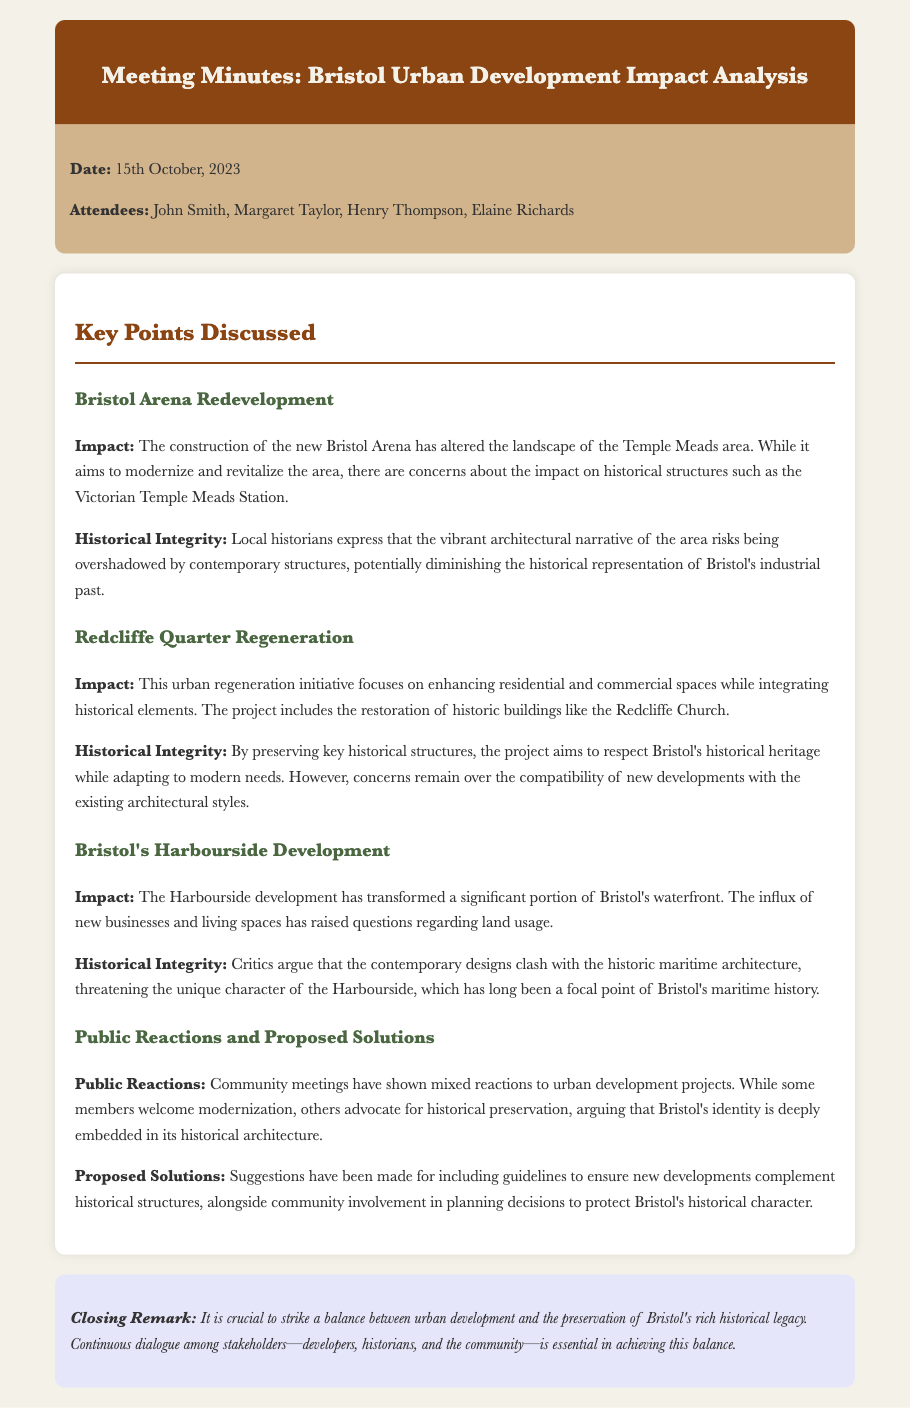What is the date of the meeting? The date of the meeting is specified in the meeting info section of the document.
Answer: 15th October, 2023 Who are the attendees of the meeting? The attendees are listed in the meeting info section.
Answer: John Smith, Margaret Taylor, Henry Thompson, Elaine Richards What project is focused on enhancing residential and commercial spaces while integrating historical elements? The project is mentioned in the key points under the Redcliffe Quarter Regeneration section.
Answer: Redcliffe Quarter Regeneration What structure is at risk of being overshadowed by contemporary developments in the Bristol Arena project? The historical structure mentioned in the context of the Bristol Arena is noted in the key points section.
Answer: Victorian Temple Meads Station What do critics argue about the Harbourside development? The concerns raised by critics regarding design clashes are detailed in the Harbourside development section.
Answer: Contemporary designs clash with historic maritime architecture What is one proposed solution to the concerns about urban development? A proposed solution to balance modernization and historical preservation is discussed in the Public Reactions and Proposed Solutions section.
Answer: Including guidelines to ensure new developments complement historical structures What is the closing remark about the significance of urban development and historical preservation? The closing remark emphasizes the importance of a collaborative approach among stakeholders for balancing development and preservation.
Answer: Strike a balance between urban development and the preservation of Bristol's rich historical legacy 